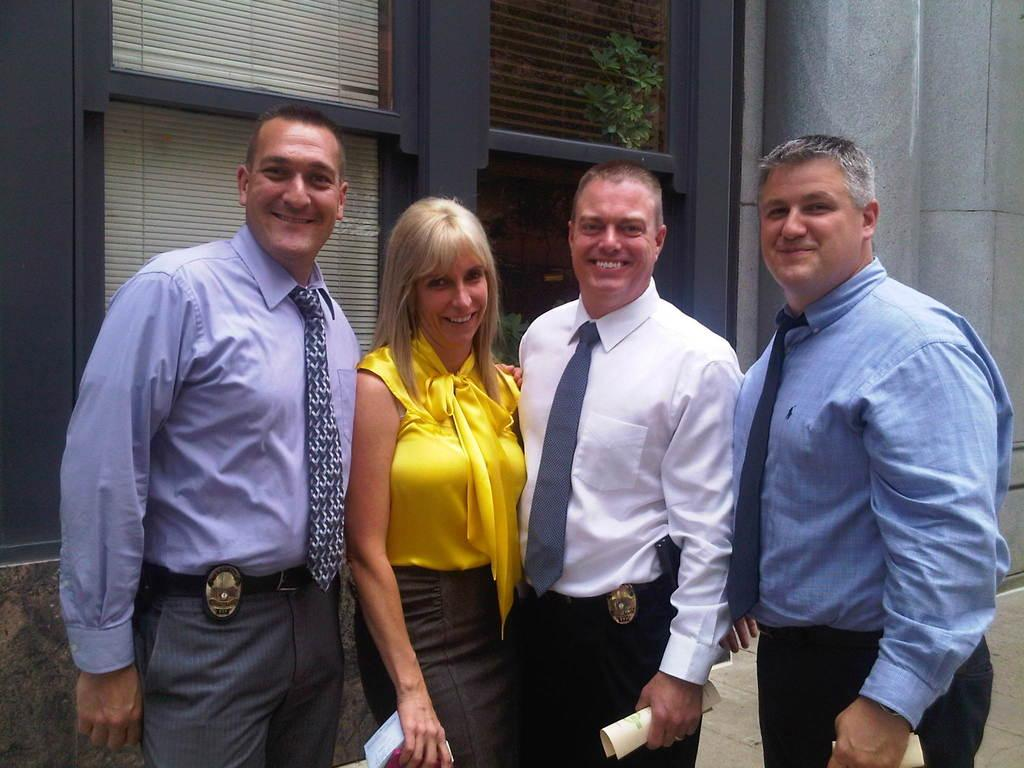How many people are in the image? There are three men and a woman in the image, making a total of four people. What are some of the people holding in their hands? Three of the people are holding papers in their hands. What can be seen in the background of the image? There are windows, a house plant, and pillars in the background of the image. What type of soup is being served in the image? There is no soup present in the image. What color are the jeans worn by the woman in the image? There is no mention of jeans or any clothing in the image; the focus is on the people holding papers and the background elements. 